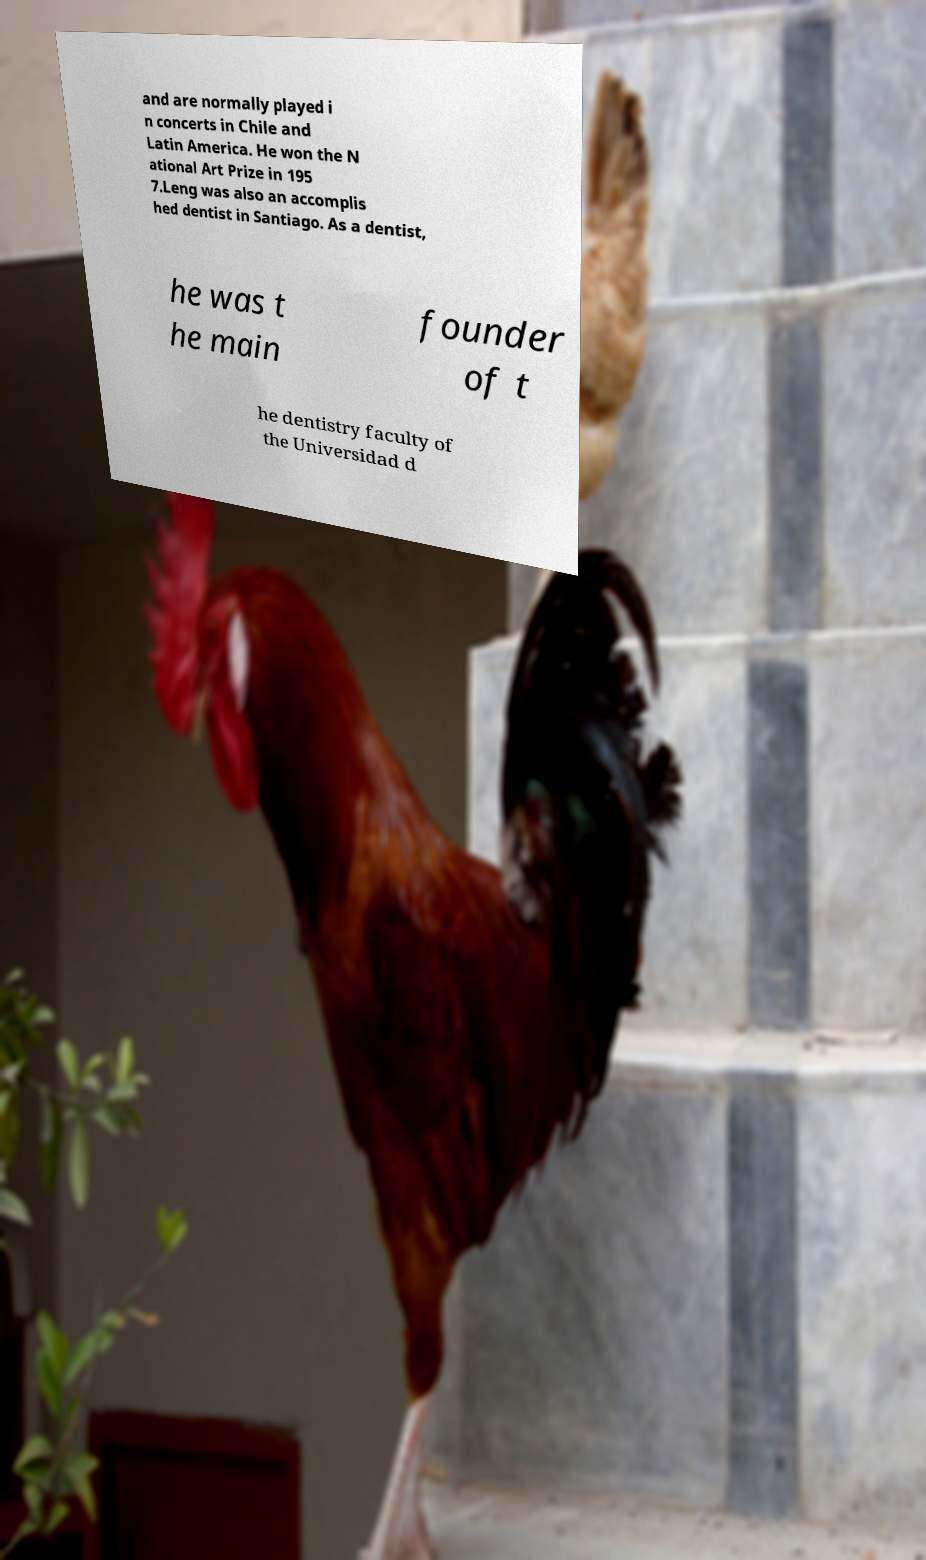Please read and relay the text visible in this image. What does it say? and are normally played i n concerts in Chile and Latin America. He won the N ational Art Prize in 195 7.Leng was also an accomplis hed dentist in Santiago. As a dentist, he was t he main founder of t he dentistry faculty of the Universidad d 